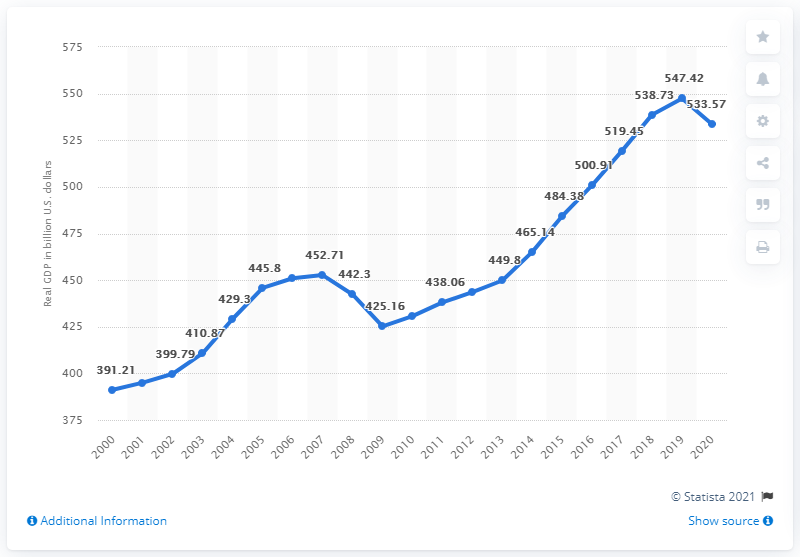Point out several critical features in this image. In 2020, the real GDP of Georgia was $533.57 in dollars. 